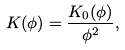Convert formula to latex. <formula><loc_0><loc_0><loc_500><loc_500>K ( \phi ) = \frac { K _ { 0 } ( \phi ) } { \phi ^ { 2 } } ,</formula> 